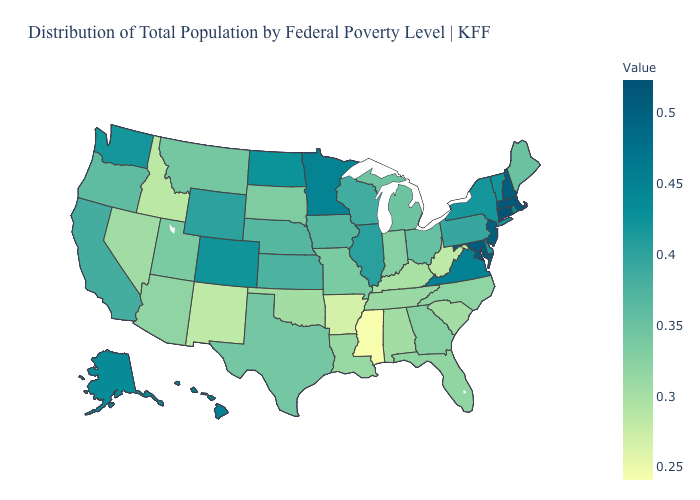Among the states that border Arkansas , does Mississippi have the lowest value?
Write a very short answer. Yes. Does Connecticut have the highest value in the USA?
Short answer required. Yes. Which states hav the highest value in the MidWest?
Be succinct. Minnesota. Among the states that border New York , which have the highest value?
Short answer required. Connecticut. Among the states that border Oklahoma , which have the highest value?
Short answer required. Colorado. Among the states that border Delaware , does Pennsylvania have the lowest value?
Keep it brief. Yes. 